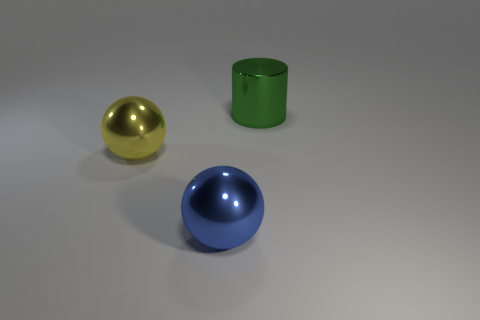Is there any other thing that is the same shape as the green object?
Ensure brevity in your answer.  No. What number of other objects are the same color as the shiny cylinder?
Make the answer very short. 0. What number of things are big things or big green metallic things?
Offer a terse response. 3. There is a large metallic thing that is left of the blue metallic ball; is its shape the same as the blue metallic thing?
Offer a terse response. Yes. The ball behind the big ball that is on the right side of the large yellow metal object is what color?
Provide a succinct answer. Yellow. Is the number of yellow matte spheres less than the number of yellow metallic things?
Offer a terse response. Yes. Is there a yellow ball that has the same material as the large blue object?
Ensure brevity in your answer.  Yes. There is a big blue metallic object; is its shape the same as the big thing on the right side of the blue thing?
Offer a terse response. No. There is a large yellow metal object; are there any big blue metallic balls to the left of it?
Your answer should be very brief. No. How many large cyan rubber things are the same shape as the yellow metallic object?
Offer a very short reply. 0. 